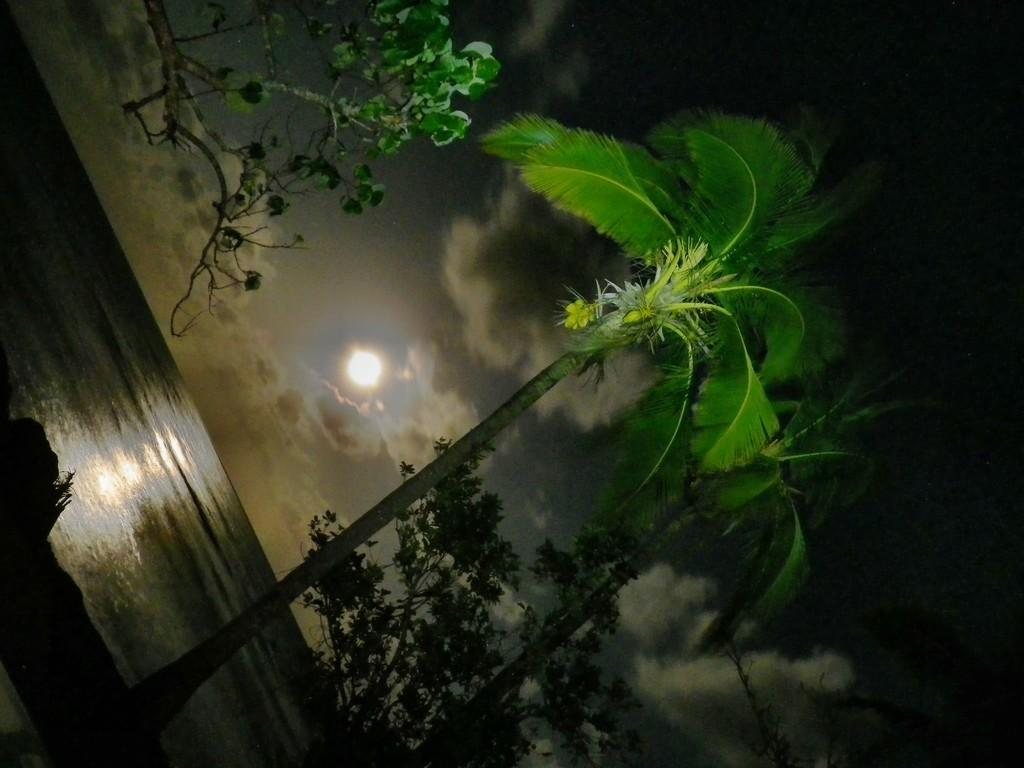What is located in the top left corner of the image? There is a tree in the top left corner of the image. What can be seen at the bottom of the image? There are trees at the bottom of the image. What celestial object is visible in the background of the image? There is a moon visible in the background of the image. What else can be seen in the sky in the background of the image? There are clouds in the sky in the background of the image. How many patches of fuel can be seen on the tree in the image? There are no patches of fuel present on the tree in the image. What type of drop is falling from the moon in the image? There are no drops falling from the moon in the image. 